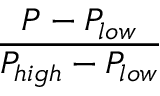<formula> <loc_0><loc_0><loc_500><loc_500>\frac { P - P _ { l o w } } { P _ { h i g h } - P _ { l o w } }</formula> 